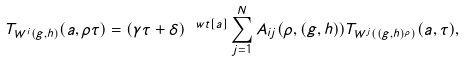<formula> <loc_0><loc_0><loc_500><loc_500>T _ { W ^ { i } ( g , h ) } ( a , \rho \tau ) = ( \gamma \tau + \delta ) ^ { \ w t [ a ] } \sum _ { j = 1 } ^ { N } A _ { i j } ( \rho , ( g , h ) ) T _ { W ^ { j } ( ( g , h ) ^ { \rho } ) } ( a , \tau ) ,</formula> 